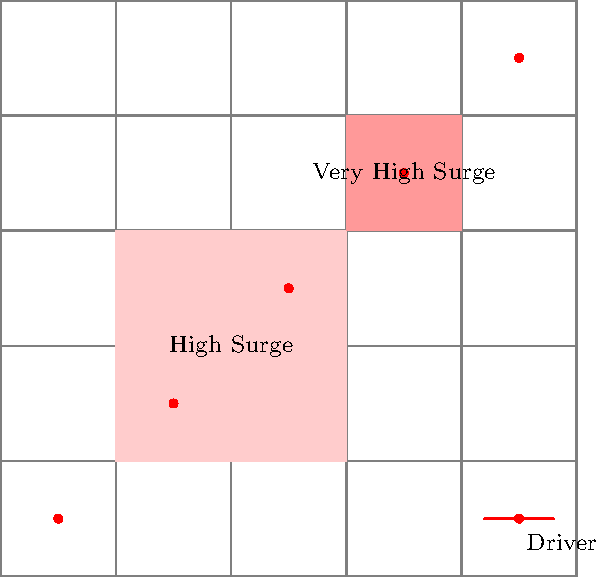In the given visual representation of surge pricing zones, what percentage of drivers are located within surge pricing areas? To solve this problem, we need to follow these steps:

1. Count the total number of drivers on the map:
   There are 5 drivers represented by red dots.

2. Identify the surge pricing zones:
   There are two surge pricing zones:
   a) A larger "High Surge" zone (light red)
   b) A smaller "Very High Surge" zone (dark red)

3. Count the number of drivers within surge pricing zones:
   - 1 driver in the "High Surge" zone
   - 1 driver in the "Very High Surge" zone
   Total drivers in surge zones: 2

4. Calculate the percentage:
   Percentage = (Drivers in surge zones / Total drivers) * 100
   $$ \text{Percentage} = \frac{2}{5} \times 100 = 40\% $$

Therefore, 40% of the drivers are located within surge pricing areas.
Answer: 40% 